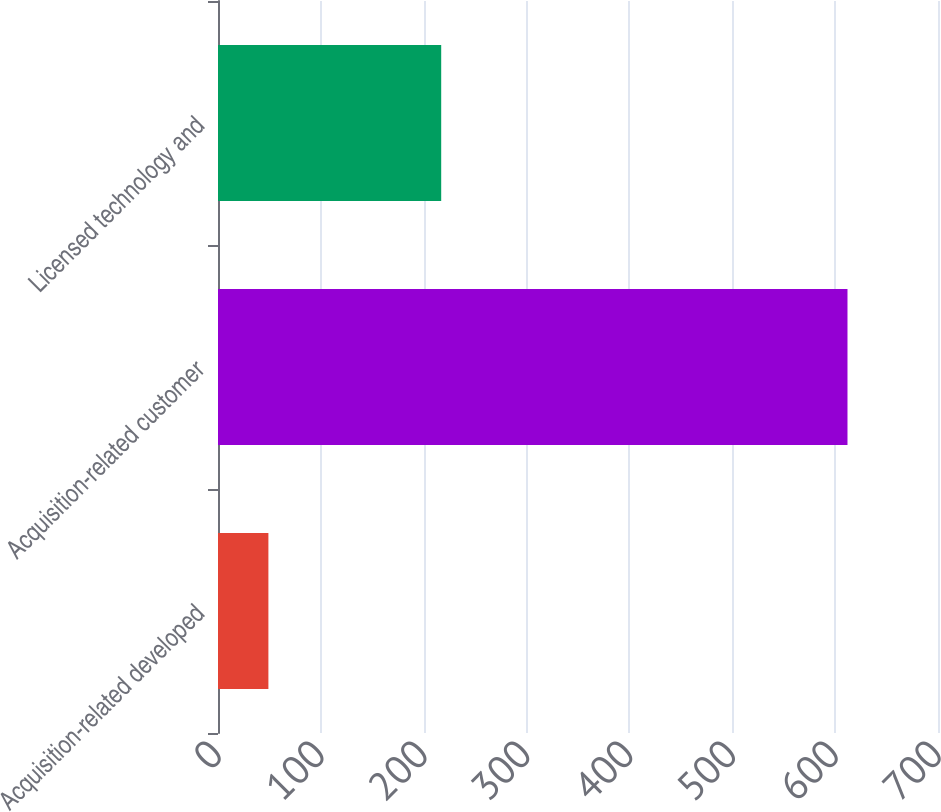Convert chart to OTSL. <chart><loc_0><loc_0><loc_500><loc_500><bar_chart><fcel>Acquisition-related developed<fcel>Acquisition-related customer<fcel>Licensed technology and<nl><fcel>49<fcel>612<fcel>217<nl></chart> 